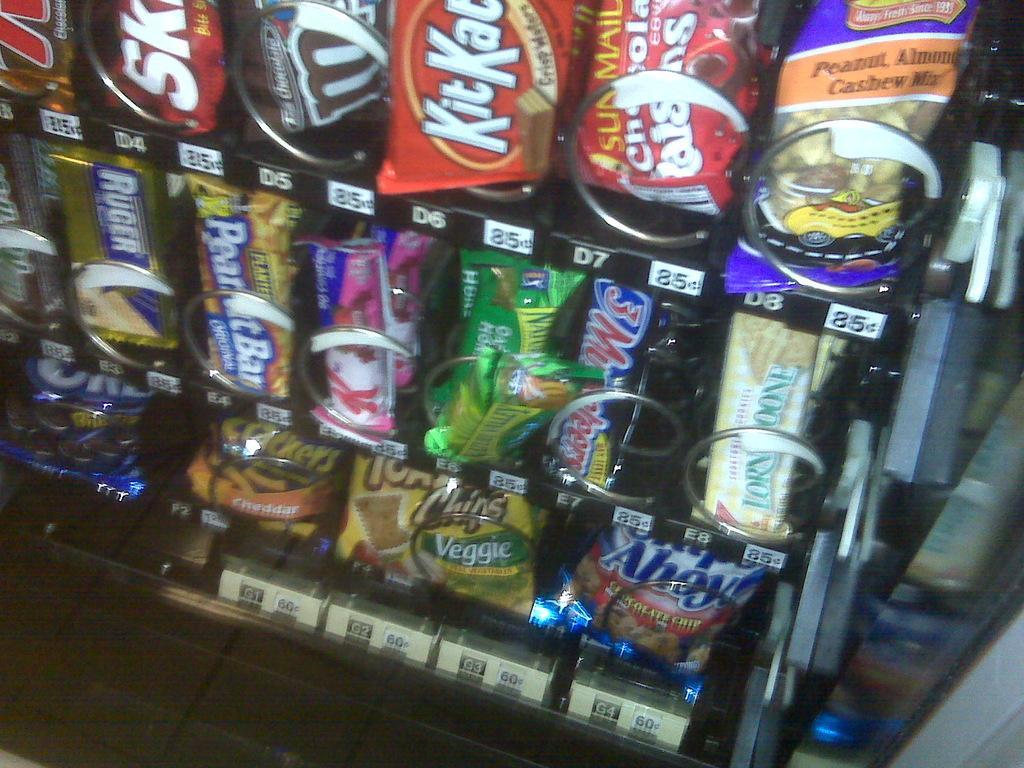In one or two sentences, can you explain what this image depicts? In this image there are so many food items are arranged in the rack and there are some labels on it. 